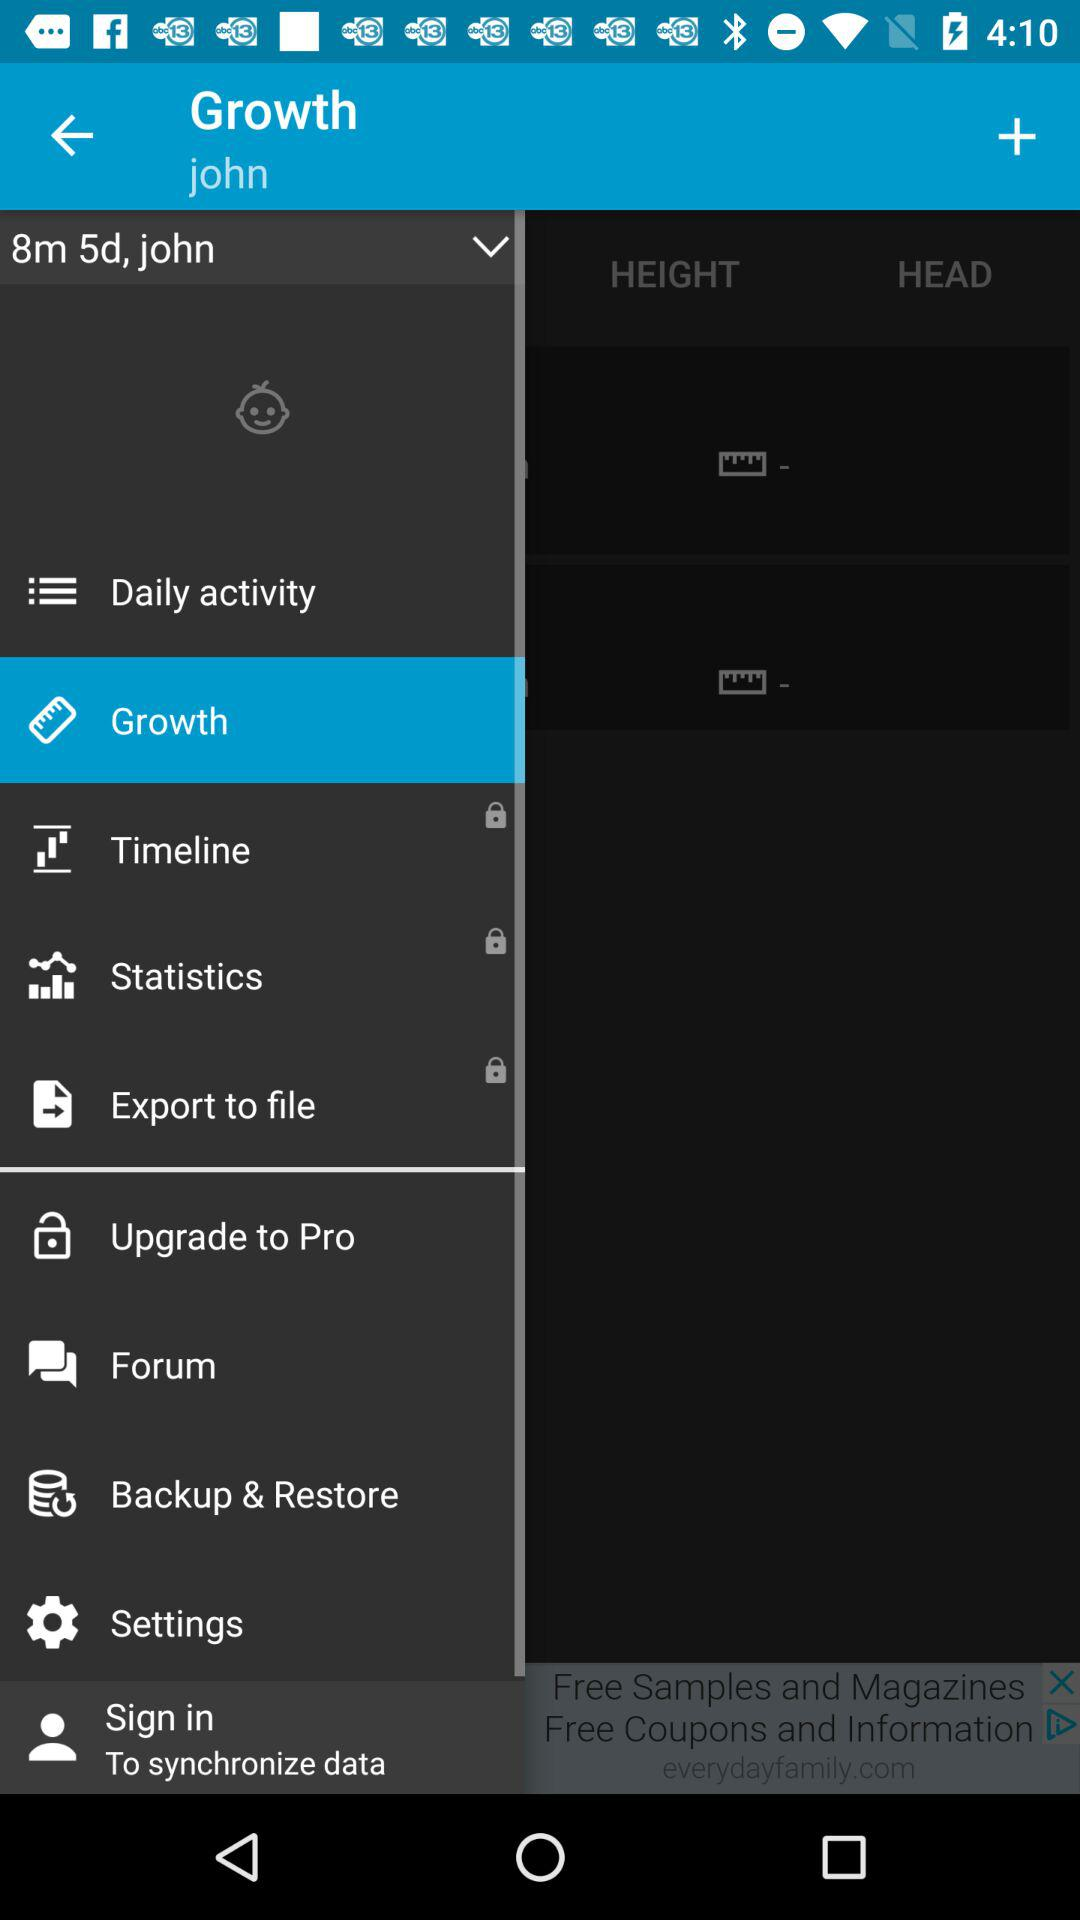What is the name of the user? The name of the user is John. 